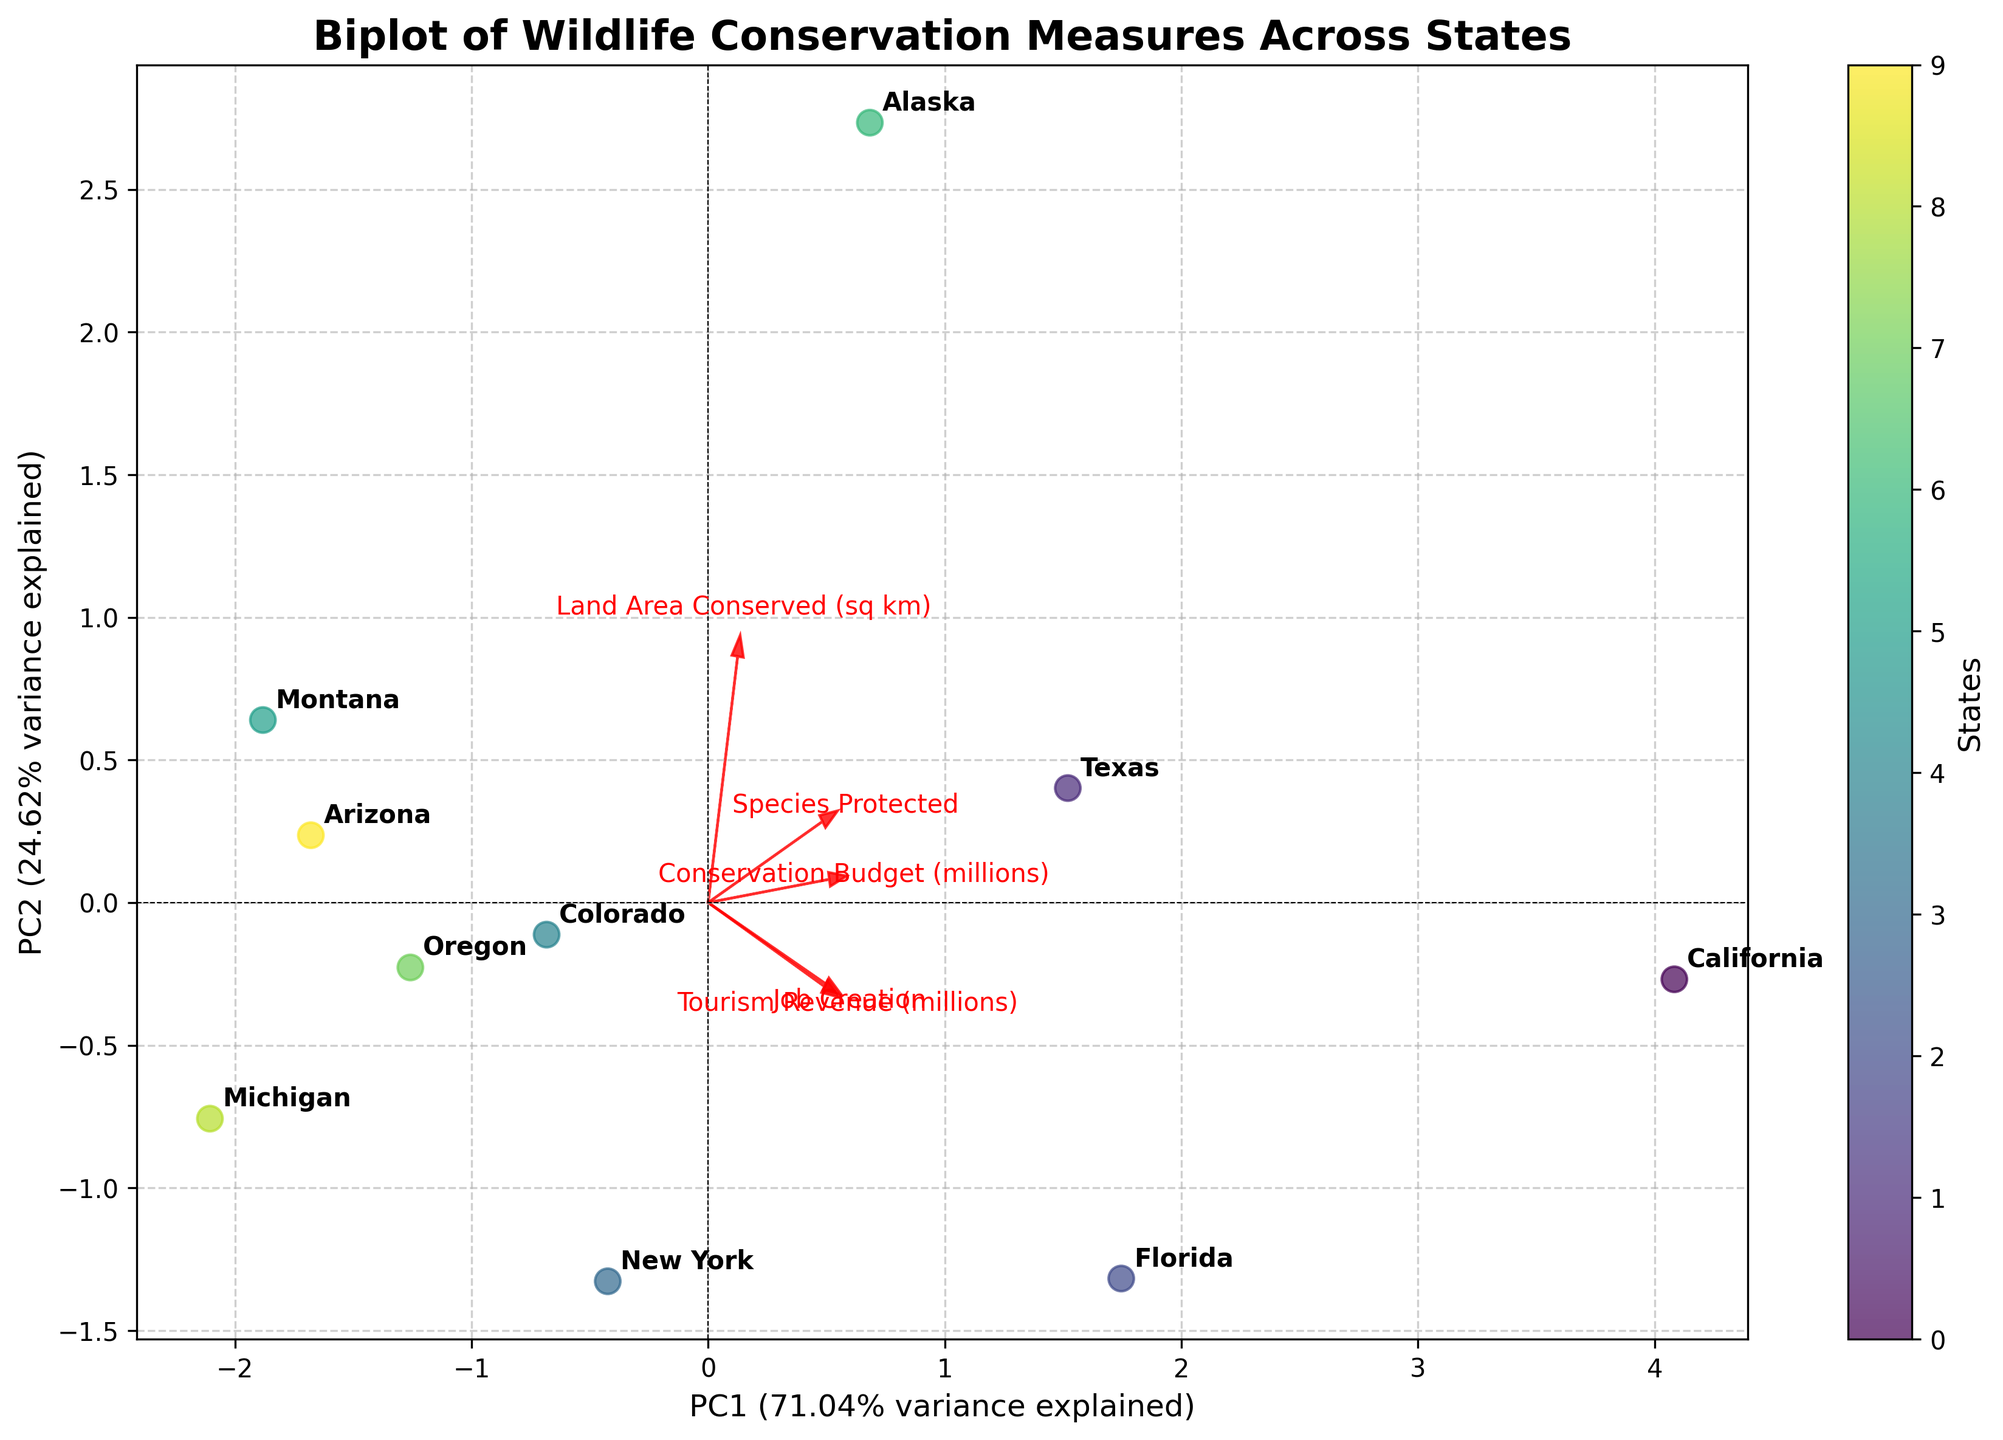What is the title of the plot? The title can be seen at the top of the plot. In this case, it reads "Biplot of Wildlife Conservation Measures Across States".
Answer: Biplot of Wildlife Conservation Measures Across States How many states are represented in the plot? Each state's name is annotated at the data points. Counting these annotations gives the number of states.
Answer: 10 Which state has the highest value along the first principal component (PC1)? By examining the plot, locate the data point farthest along the positive or negative direction of the PC1 axis (horizontal).
Answer: Texas Which state is most positively correlated with "Tourism Revenue (millions)"? Identify the direction of the arrow representing "Tourism Revenue (millions)", then find the state closest to the arrow's direction.
Answer: Florida What does the horizontal axis represent? The x-axis label shows this information. It represents the 'PC1' and indicates the percentage variance explained.
Answer: PC1 Which conservation measure contributes most to PC2? Look for the vector (arrow) with the largest component along the vertical axis (PC2).
Answer: Land Area Conserved (sq km) Compare the positions of California and Montana. Which principal component explains their main differences? Determine the principal component along which they are most separated horizontally or vertically.
Answer: PC1 What is the explained variance of PC1? This information is given by the label on the horizontal axis. It shows the percentage of variance explained by PC1.
Answer: 47.00% Are "Job Creation" and "Tourism Revenue (millions)" positively correlated? Check if the arrows representing these features point in similar directions.
Answer: Yes Which state is the most negatively correlated with "Land Area Conserved (sq km)"? Identify the direction of the "Land Area Conserved (sq km)" vector and find the state farthest in the opposite direction.
Answer: New York 